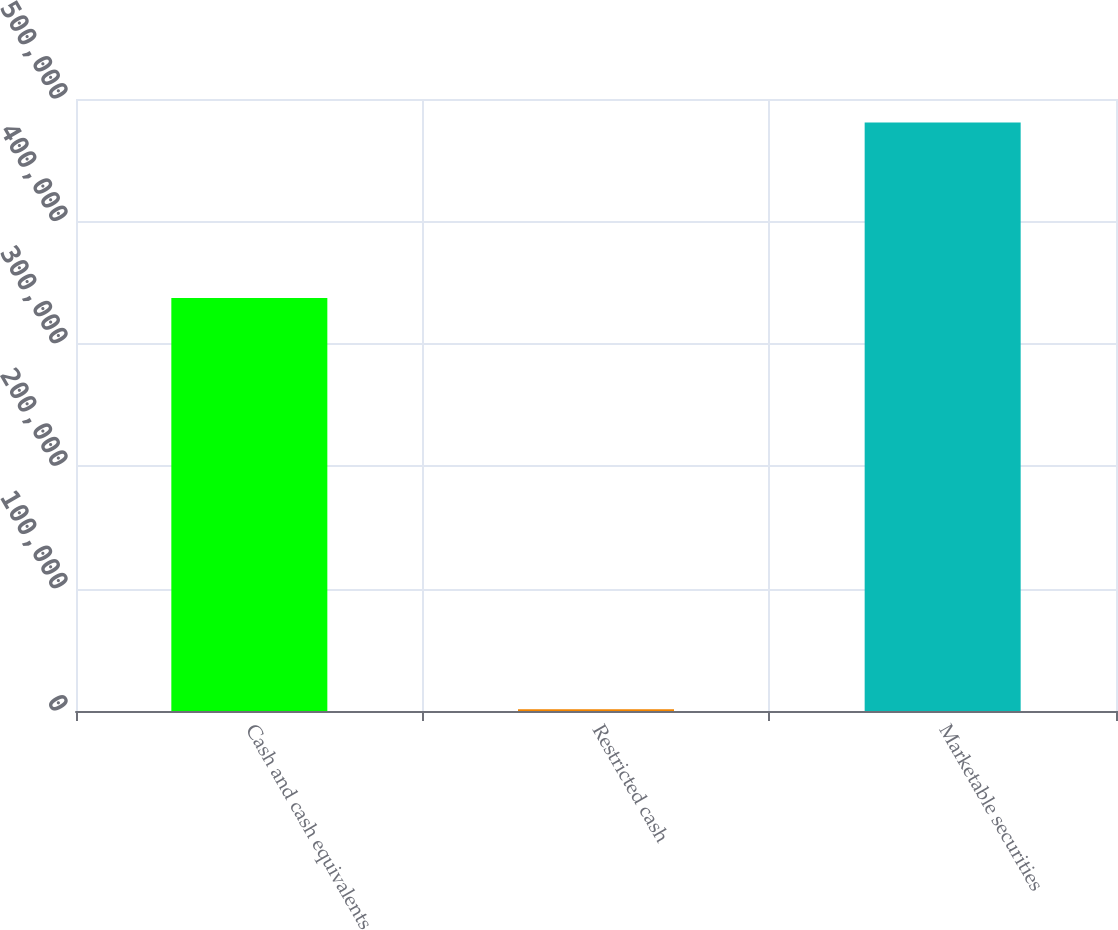Convert chart to OTSL. <chart><loc_0><loc_0><loc_500><loc_500><bar_chart><fcel>Cash and cash equivalents<fcel>Restricted cash<fcel>Marketable securities<nl><fcel>337321<fcel>1525<fcel>480876<nl></chart> 